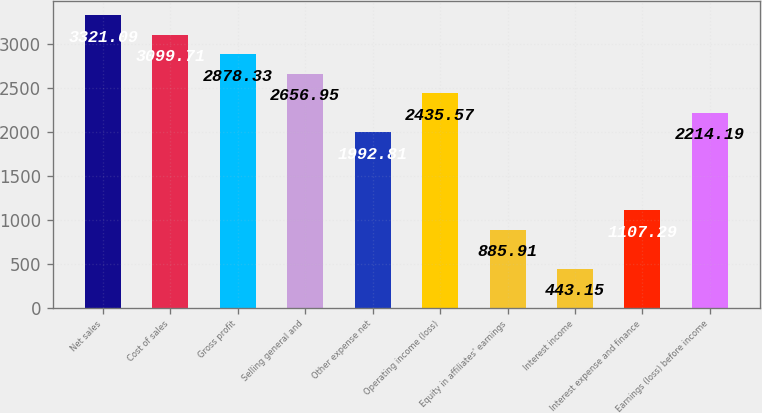<chart> <loc_0><loc_0><loc_500><loc_500><bar_chart><fcel>Net sales<fcel>Cost of sales<fcel>Gross profit<fcel>Selling general and<fcel>Other expense net<fcel>Operating income (loss)<fcel>Equity in affiliates' earnings<fcel>Interest income<fcel>Interest expense and finance<fcel>Earnings (loss) before income<nl><fcel>3321.09<fcel>3099.71<fcel>2878.33<fcel>2656.95<fcel>1992.81<fcel>2435.57<fcel>885.91<fcel>443.15<fcel>1107.29<fcel>2214.19<nl></chart> 